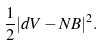Convert formula to latex. <formula><loc_0><loc_0><loc_500><loc_500>\frac { 1 } { 2 } | d V - N B | ^ { 2 } .</formula> 